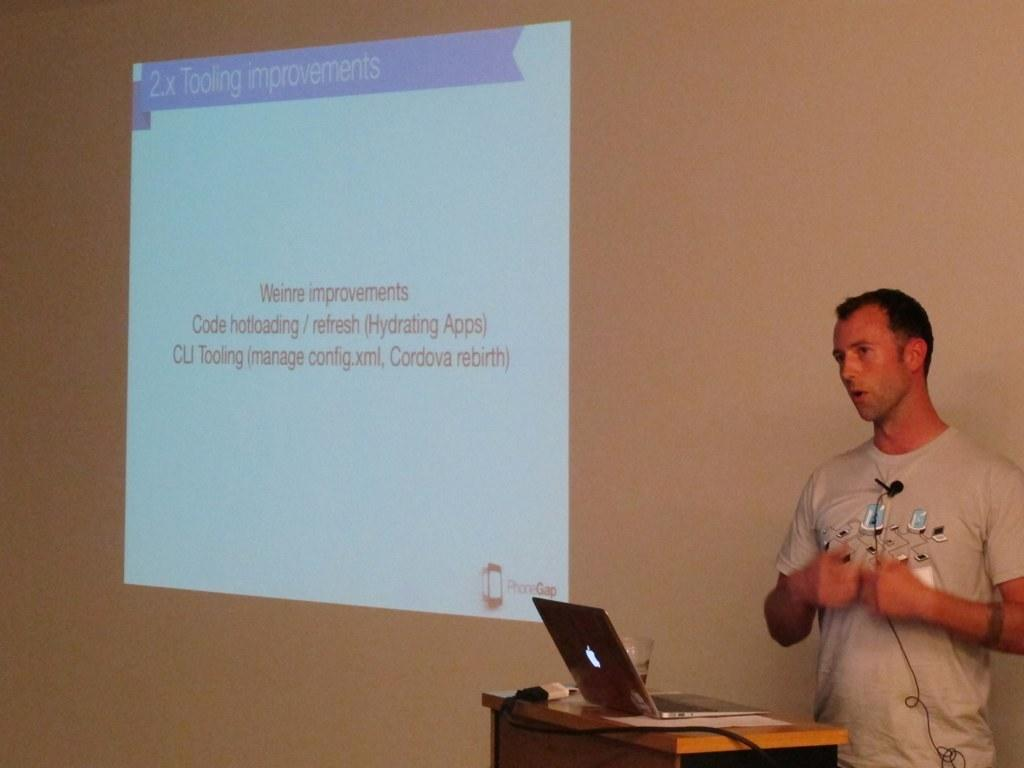What is the person on the right side of the image doing? There is a guy standing on the right side of the image. What is the guy holding on his shirt? The guy is holding a mic on his shirt. What object is on the desk in front of the guy? There is a laptop on a desk in front of the guy. What can be seen on the wall in the image? There is a projector screen projection on the wall. Can you tell me how many pigs are visible in the image? There are no pigs present in the image. What type of lock is used to secure the laptop in the image? There is no lock visible in the image, and the laptop is not secured. 